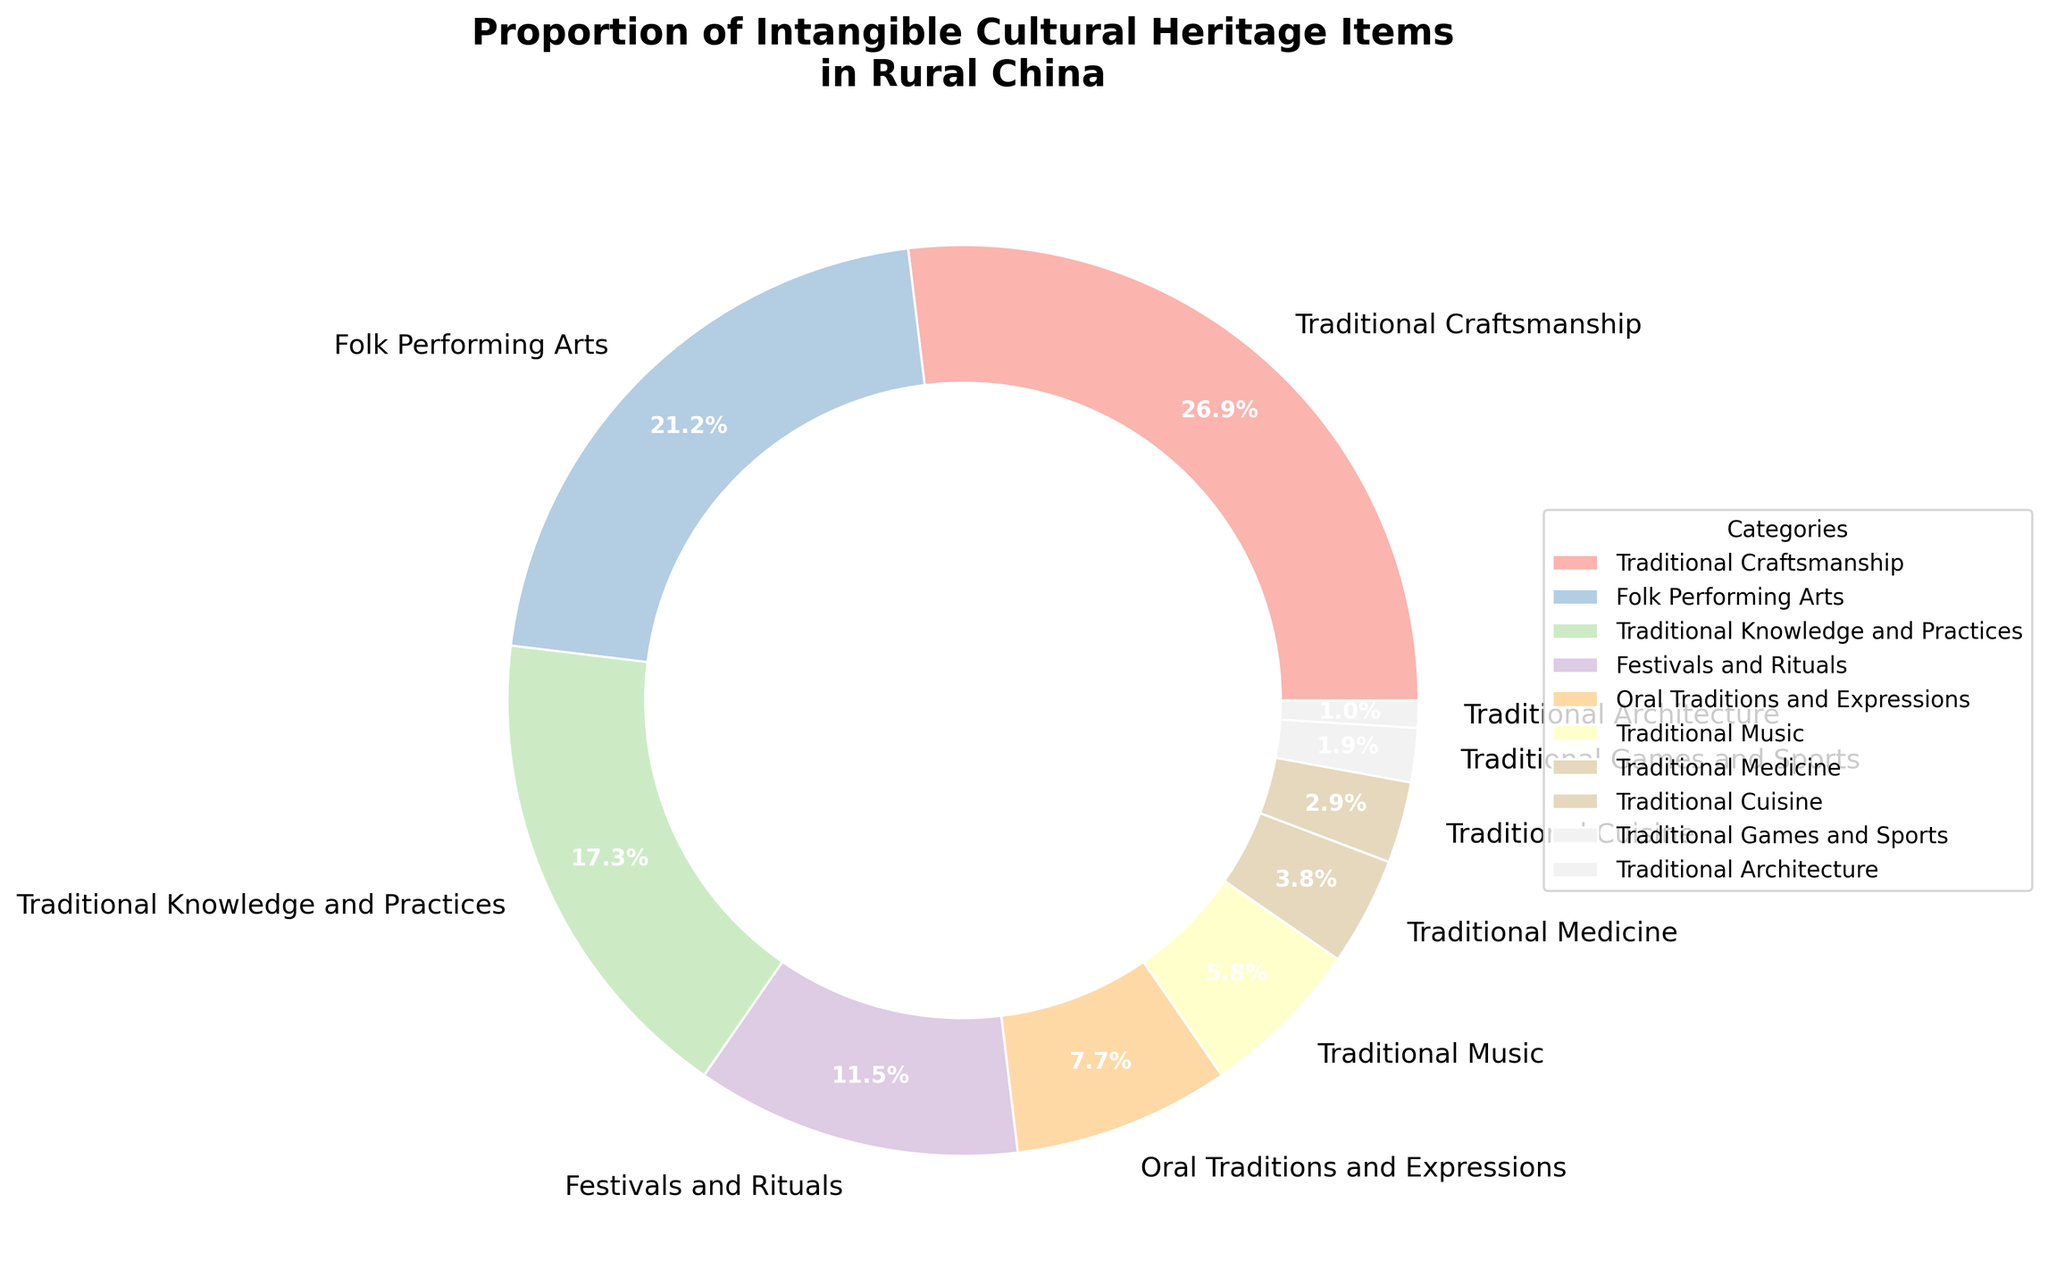What's the category with the highest proportion of intangible cultural heritage items? By observing the largest wedge in the pie chart, we can see that "Traditional Craftsmanship" occupies the largest proportion, which is 28%.
Answer: Traditional Craftsmanship Which category has a proportion double that of Traditional Cuisine? Traditional Cuisine has a proportion of 3%. Doubling this would be 3% * 2 = 6%. By observing the pie chart, "Traditional Music" has a proportion of 6%.
Answer: Traditional Music What is the combined proportion of Folk Performing Arts and Traditional Knowledge and Practices? Folk Performing Arts has a proportion of 22%, and Traditional Knowledge and Practices has a proportion of 18%. Adding these gives 22% + 18% = 40%.
Answer: 40% How much smaller is the proportion of Oral Traditions and Expressions compared to Traditional Craftsmanship? Traditional Craftsmanship has a proportion of 28%, and Oral Traditions and Expressions has a proportion of 8%. The difference is 28% - 8% = 20%.
Answer: 20% Which category has a proportion less than 5%? List all that apply. Observing the pie chart slices, the categories with less than 5% are Traditional Medicine (4%), Traditional Cuisine (3%), Traditional Games and Sports (2%), and Traditional Architecture (1%).
Answer: Traditional Medicine, Traditional Cuisine, Traditional Games and Sports, Traditional Architecture What's the sum of the proportions of the three smallest categories? The three smallest categories are Traditional Architecture (1%), Traditional Games and Sports (2%), and Traditional Cuisine (3%). Adding these gives 1% + 2% + 3% = 6%.
Answer: 6% Which is greater, Traditional Music or Traditional Medicine, and by how much? Traditional Music has a proportion of 6%, and Traditional Medicine has a proportion of 4%. The difference is 6% - 4% = 2%. Therefore, Traditional Music is greater by 2%.
Answer: Traditional Music, 2% What's the average proportion of Festivals and Rituals, Oral Traditions and Expressions, and Traditional Music? The proportions are Festivals and Rituals (12%), Oral Traditions and Expressions (8%), and Traditional Music (6%). The sum is 12% + 8% + 6% = 26%. Dividing this by 3 gives an average of 26% / 3 ≈ 8.67%.
Answer: 8.67% Which category is represented by the blue wedge, and what is its proportion? By visually identifying the blue wedge in the pie chart, we see it corresponds to Oral Traditions and Expressions, which has a proportion of 8%.
Answer: Oral Traditions and Expressions, 8% Is the proportion of Traditional Knowledge and Practices greater than the sum of Traditional Medicine and Traditional Cuisine? Traditional Knowledge and Practices has a proportion of 18%. The sum of Traditional Medicine (4%) and Traditional Cuisine (3%) is 4% + 3% = 7%. Since 18% > 7%, Traditional Knowledge and Practices has a greater proportion.
Answer: Yes 